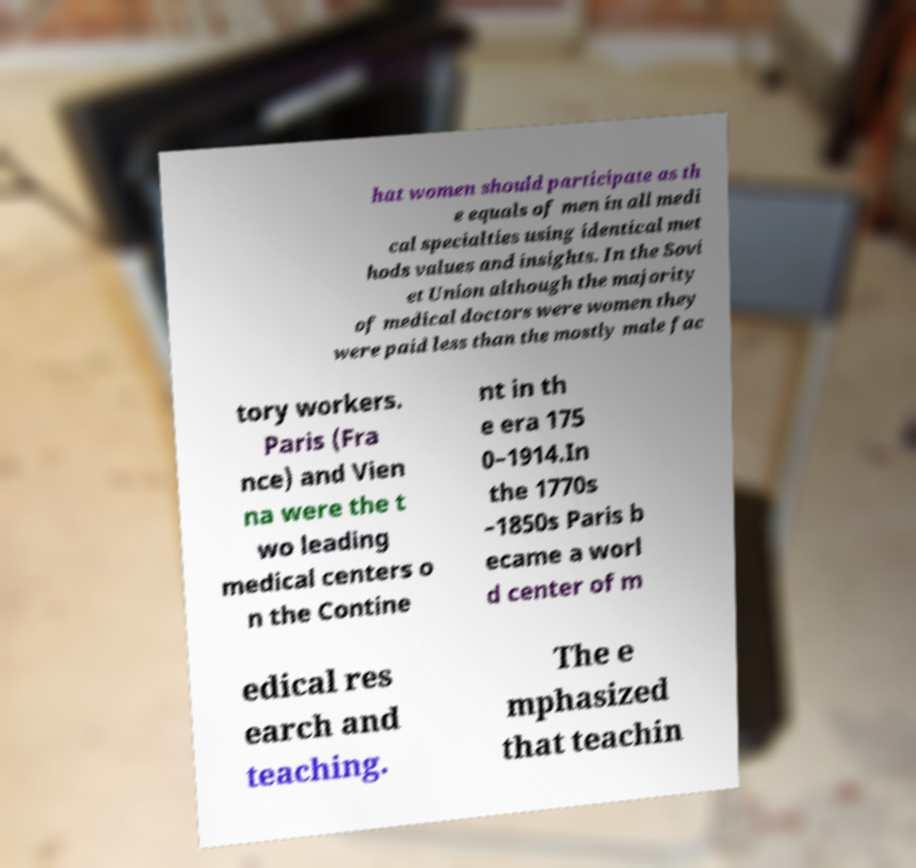I need the written content from this picture converted into text. Can you do that? hat women should participate as th e equals of men in all medi cal specialties using identical met hods values and insights. In the Sovi et Union although the majority of medical doctors were women they were paid less than the mostly male fac tory workers. Paris (Fra nce) and Vien na were the t wo leading medical centers o n the Contine nt in th e era 175 0–1914.In the 1770s –1850s Paris b ecame a worl d center of m edical res earch and teaching. The e mphasized that teachin 